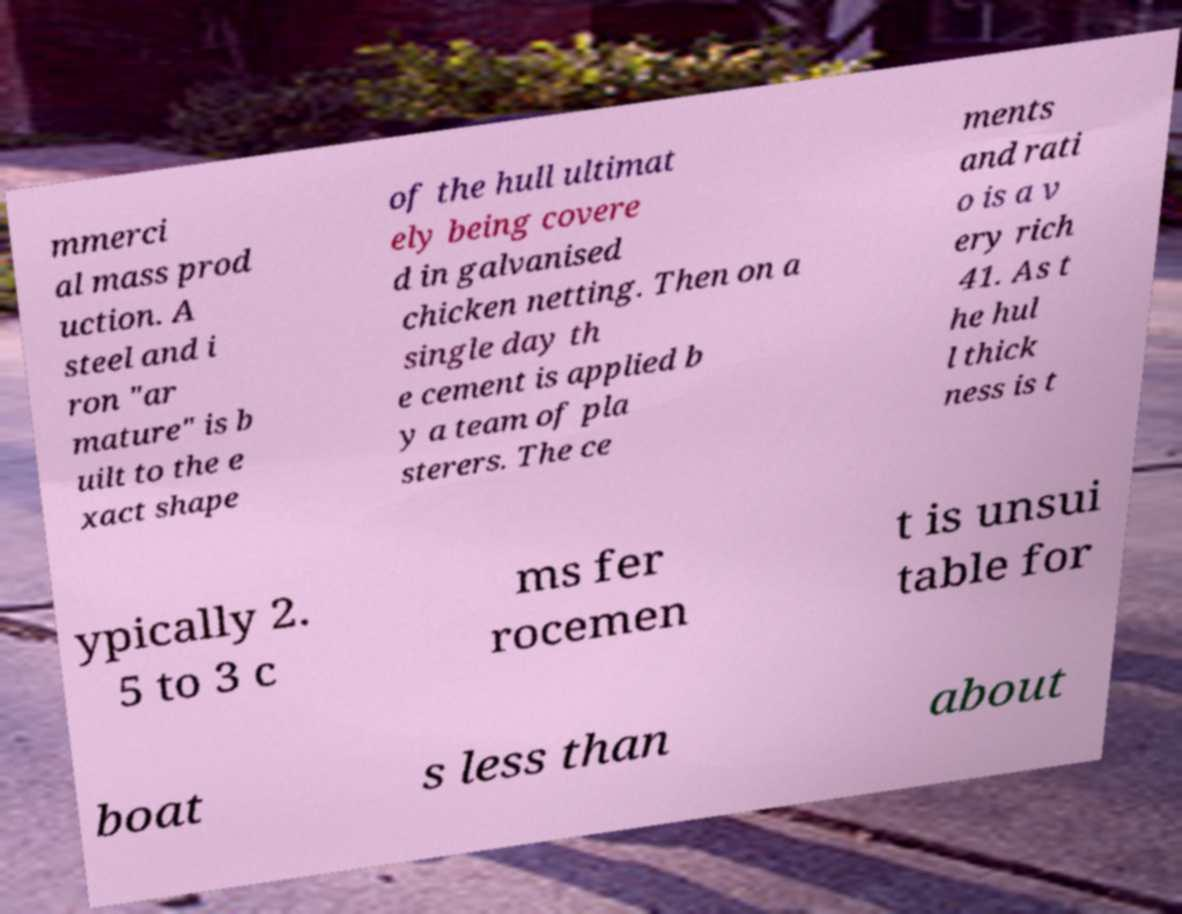Could you assist in decoding the text presented in this image and type it out clearly? mmerci al mass prod uction. A steel and i ron "ar mature" is b uilt to the e xact shape of the hull ultimat ely being covere d in galvanised chicken netting. Then on a single day th e cement is applied b y a team of pla sterers. The ce ments and rati o is a v ery rich 41. As t he hul l thick ness is t ypically 2. 5 to 3 c ms fer rocemen t is unsui table for boat s less than about 